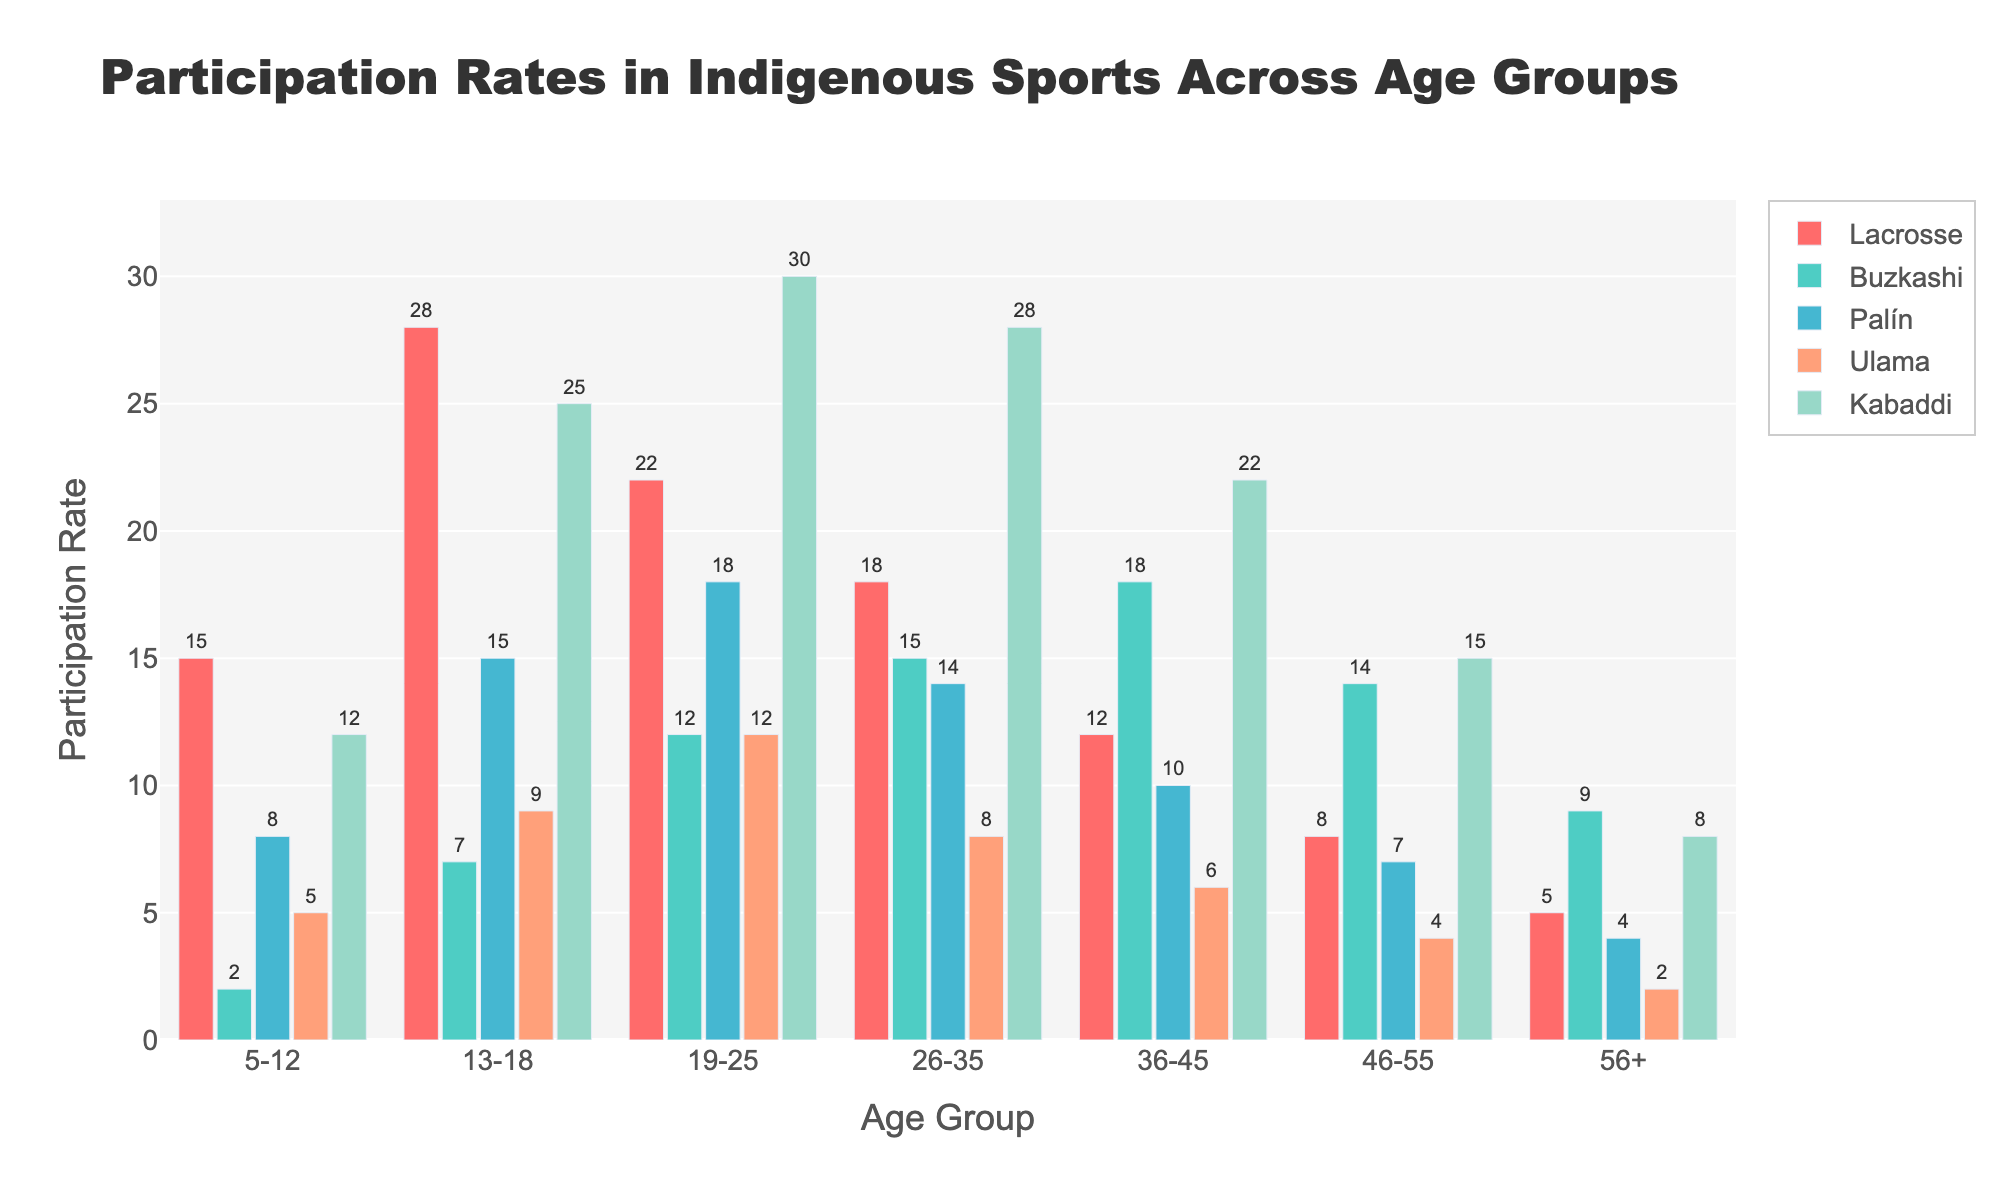Which age group has the highest participation rate in Kabaddi? The bar representing Kabaddi participation for the 19-25 age group is the tallest among all age groups.
Answer: 19-25 Which sport has the lowest participation rate in the 5-12 age group? Observing the bars for the 5-12 age group, Buzkashi has the shortest bar, indicating the lowest participation rate.
Answer: Buzkashi How does the participation rate for Palín in the 26-35 age group compare to the rate for Buzkashi in the same age group? The bar for Palín is slightly shorter than the bar for Buzkashi. Therefore, the participation rate for Palín is lower than that of Buzkashi in the 26-35 age group.
Answer: Lower Calculate the average participation rate across all sports for the 13-18 age group. For the 13-18 age group: (28 (Lacrosse) + 7 (Buzkashi) + 15 (Palín) + 9 (Ulama) + 25 (Kabaddi))/5 = 84/5 = 16.8.
Answer: 16.8 Compare the participation rates for Lacrosse between the 5-12 and 13-18 age groups. By how much does it increase? The participation rate for Lacrosse in the 5-12 age group is 15, and for the 13-18 age group, it is 28. The increase is 28 - 15 = 13.
Answer: 13 What is the total participation rate for Ulama across all age groups? Sum the participation rates of Ulama for all age groups: 5 + 9 + 12 + 8 + 6 + 4 + 2 = 46.
Answer: 46 